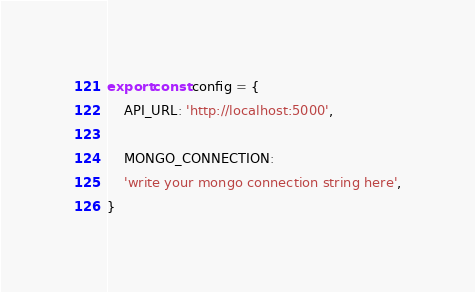<code> <loc_0><loc_0><loc_500><loc_500><_TypeScript_>export const config = {
	API_URL: 'http://localhost:5000',
	
	MONGO_CONNECTION:
	'write your mongo connection string here',
}</code> 